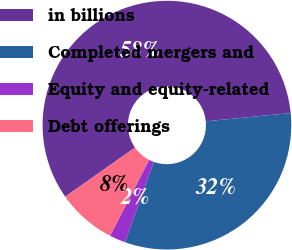Convert chart to OTSL. <chart><loc_0><loc_0><loc_500><loc_500><pie_chart><fcel>in billions<fcel>Completed mergers and<fcel>Equity and equity-related<fcel>Debt offerings<nl><fcel>58.2%<fcel>32.03%<fcel>2.08%<fcel>7.69%<nl></chart> 